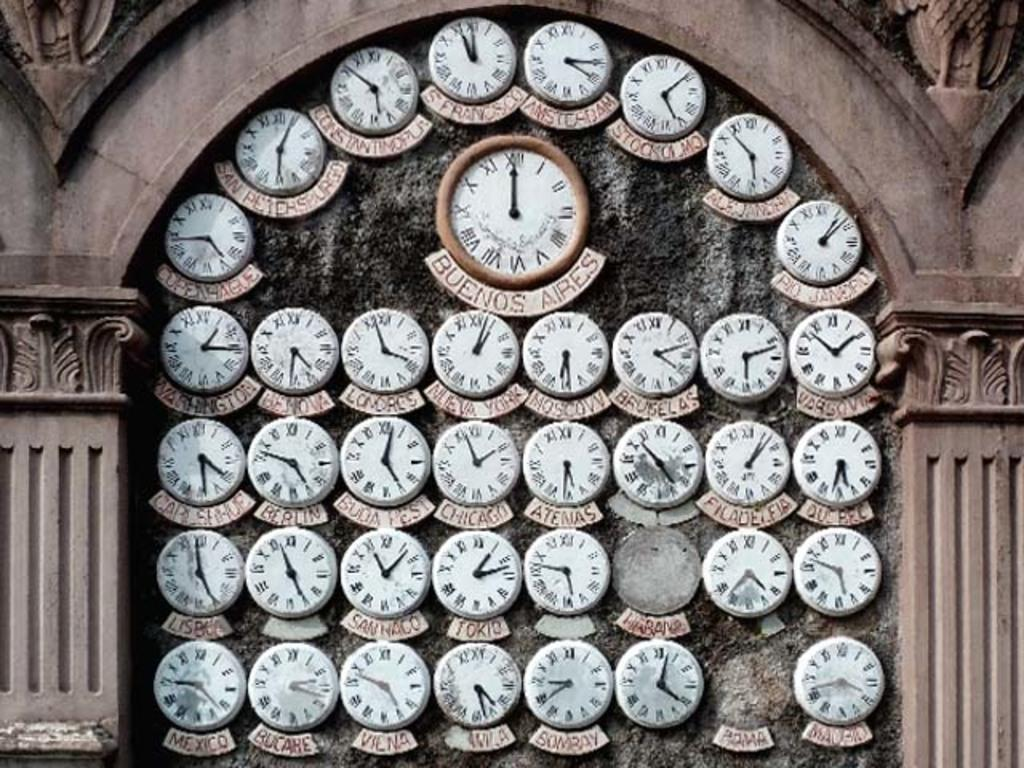<image>
Create a compact narrative representing the image presented. The clock from Buenos Aires says its midnight or noon there. 